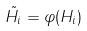Convert formula to latex. <formula><loc_0><loc_0><loc_500><loc_500>\tilde { H _ { i } } = \varphi ( H _ { i } )</formula> 